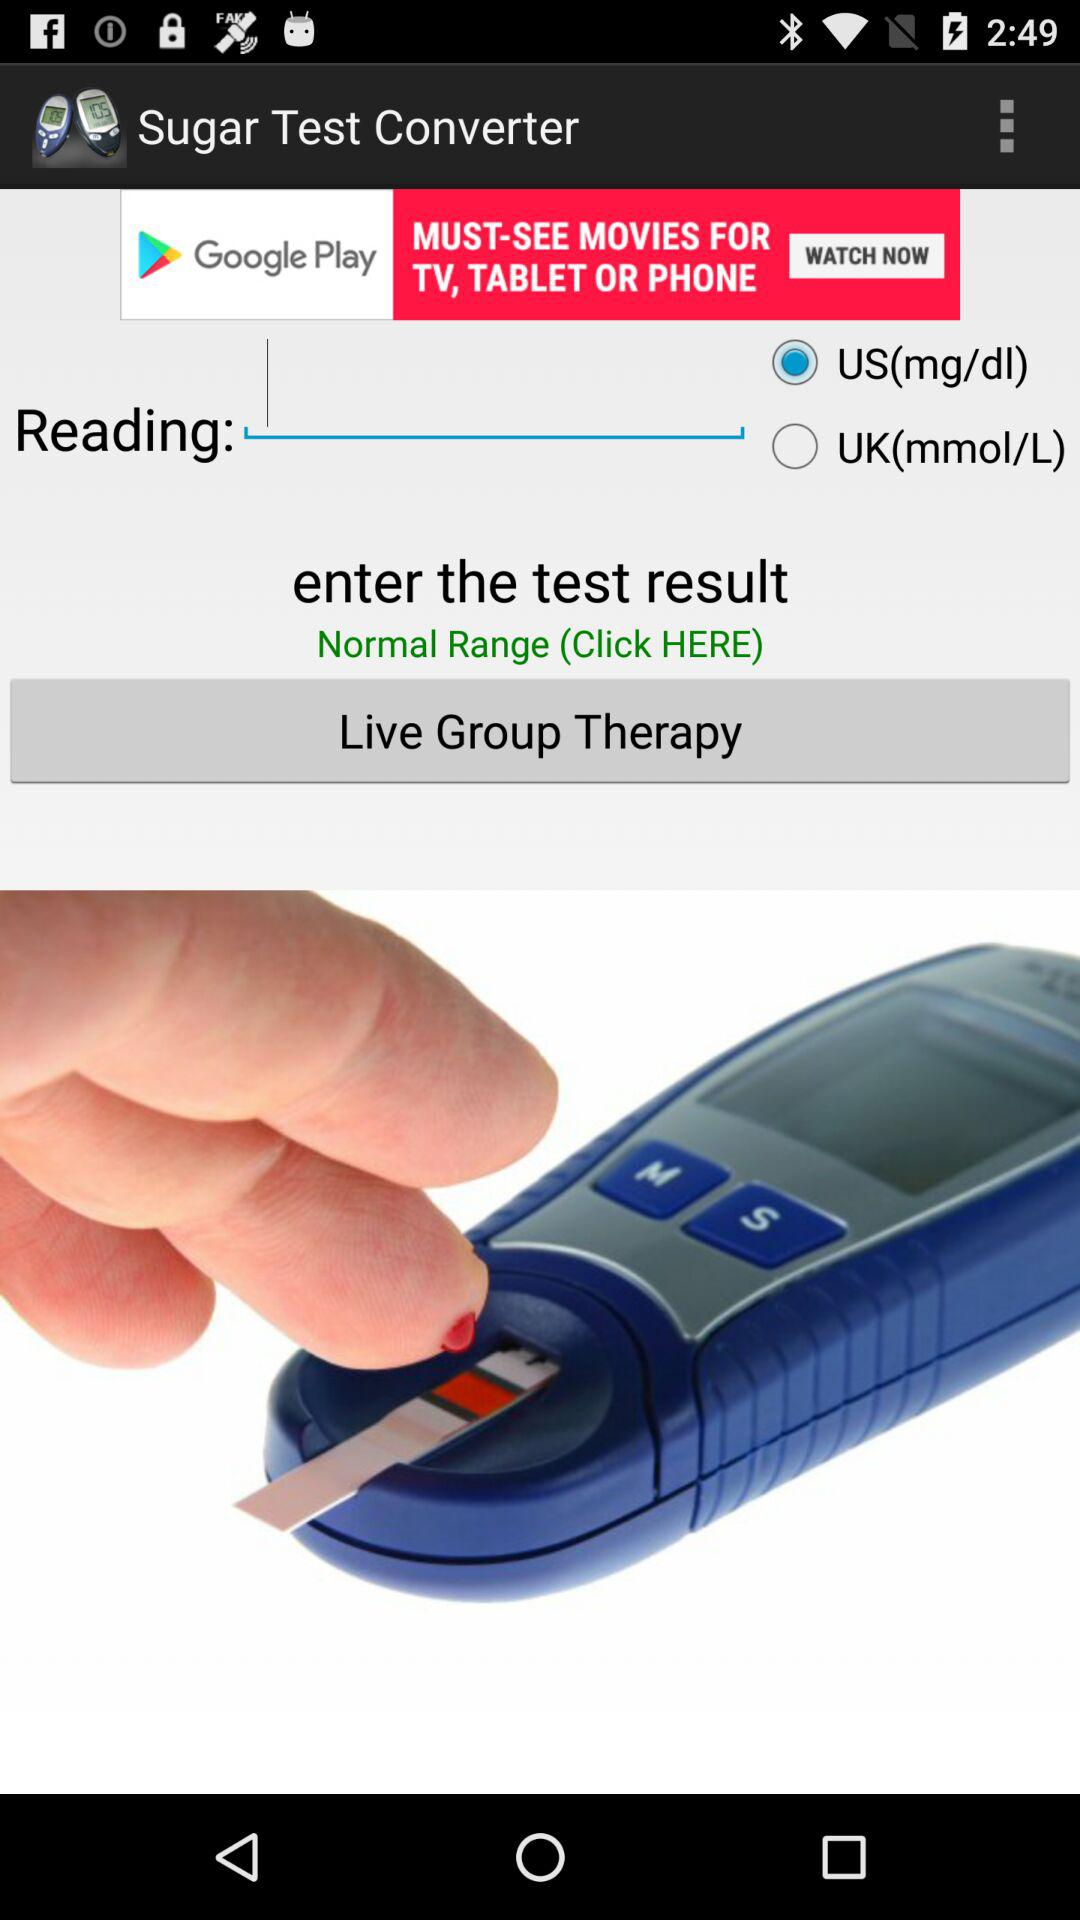How many options are there to choose the units of measurement?
Answer the question using a single word or phrase. 2 